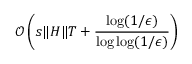Convert formula to latex. <formula><loc_0><loc_0><loc_500><loc_500>\mathcal { O } \left ( s \| H \| T + \frac { \log ( 1 / \epsilon ) } { \log \log ( 1 / \epsilon ) } \right )</formula> 